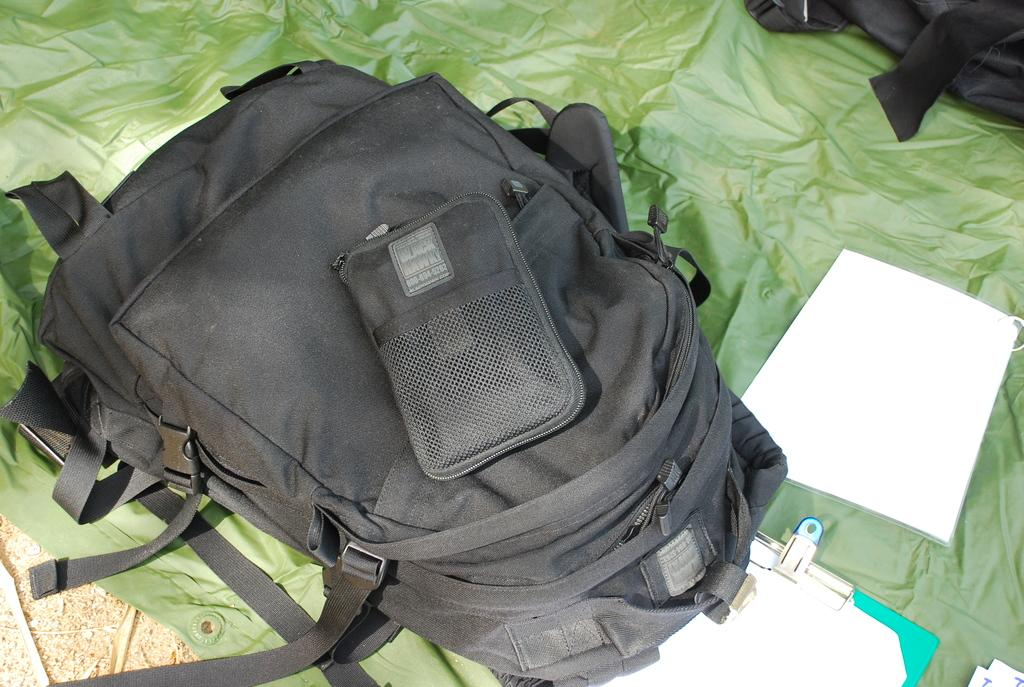What type of bag is in the image? There is a black color bag in the image. What is the other item made of paper in the image? There is a paper in the image. What is the third item in the image? There is a pad in the image. What is the color of the cloth in the image? There is a green color cloth in the image. What type of bit can be seen in the image? There is no bit present in the image. What act is being performed in the image? There is no act being performed in the image; it is a still image of objects. 